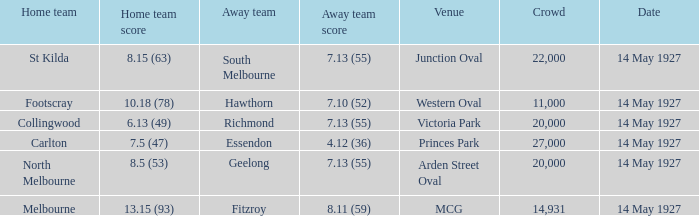Which guest team had a score of Essendon. 